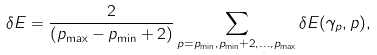Convert formula to latex. <formula><loc_0><loc_0><loc_500><loc_500>\delta { E } = \frac { 2 } { ( p _ { \max } - p _ { \min } + 2 ) } \sum _ { p = p _ { \min } , p _ { \min } + 2 , \dots , p _ { \max } } \delta { E } ( \gamma _ { p } , p ) ,</formula> 